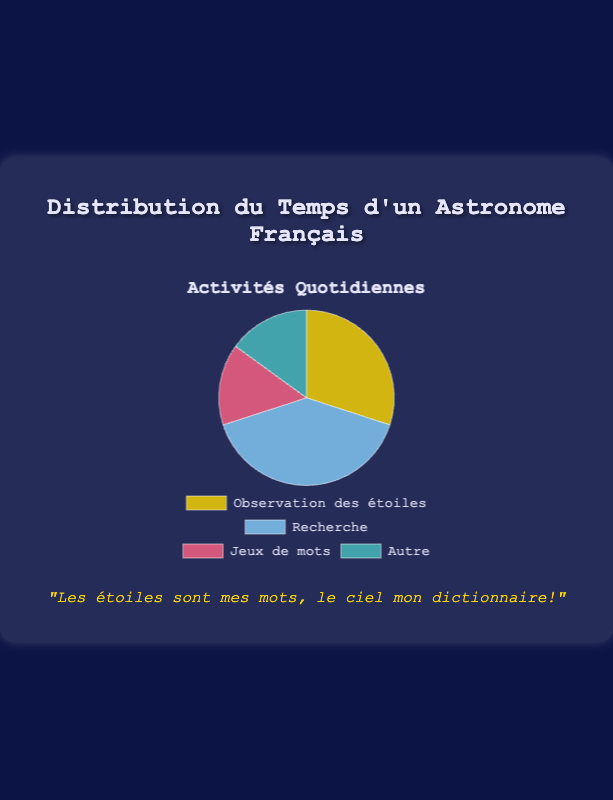Quel pourcentage du temps est consacré à l'observation des étoiles? Selon le graphique, le secteur jaune représente "Observation des étoiles". La partie correspond à 30% du temps total passé dans une journée.
Answer: 30% Quelle activité prend la plus grande partie de la journée? En comparant la taille des secteurs sur le graphique, le secteur bleu clair "Recherche" est le plus grand, représentant 40% du temps total.
Answer: Recherche Combien de temps en pourcentage est passé sur les activités autres que la recherche? Les activités autres que la recherche sont: Observation des étoiles (30%), Jeux de mots (15%), Autre (15%). En les additionnant on obtient 30% + 15% + 15% = 60%.
Answer: 60% Quelle est la différence en pourcentage de temps passé entre les activités "Jeux de mots" et "Autre"? Le pourcentage de temps passé sur "Jeux de mots" est de 15%, et sur "Autre" c'est aussi 15%. La différence est donc 15% - 15% = 0%.
Answer: 0% Quel pourcentage du temps est consacré à des activités cérébrales (Recherche et Jeux de mots)? Pour calculer, ajoutez le pourcentage de temps passé sur "Recherche" (40%) et "Jeux de mots" (15%). Donc, 40% + 15% = 55%.
Answer: 55% Quels secteurs sur le graphique ont la même taille? Les secteurs de "Jeux de mots" et "Autre" sont de la même taille sur le graphique, chacun représentant 15% du temps total.
Answer: Jeux de mots et Autre Quelle activité est représentée par le secteur rouge? Le secteur rouge sur le graphique correspond à "Jeux de mots".
Answer: Jeux de mots Si le total des temps passé sur 'Observation des étoiles' et 'Recherche' est combiné, cela représente quel pourcentage du temps total? En additionnant le temps pour "Observation des étoiles" (30%) et "Recherche" (40%), on obtient 30% + 40% = 70%.
Answer: 70% Quelle part du graphique est la plus petite? Les plus petits secteurs de ce graphique sont "Jeux de mots" et "Autre", chacun représentant 15% du temps total.
Answer: Jeux de mots et Autre 